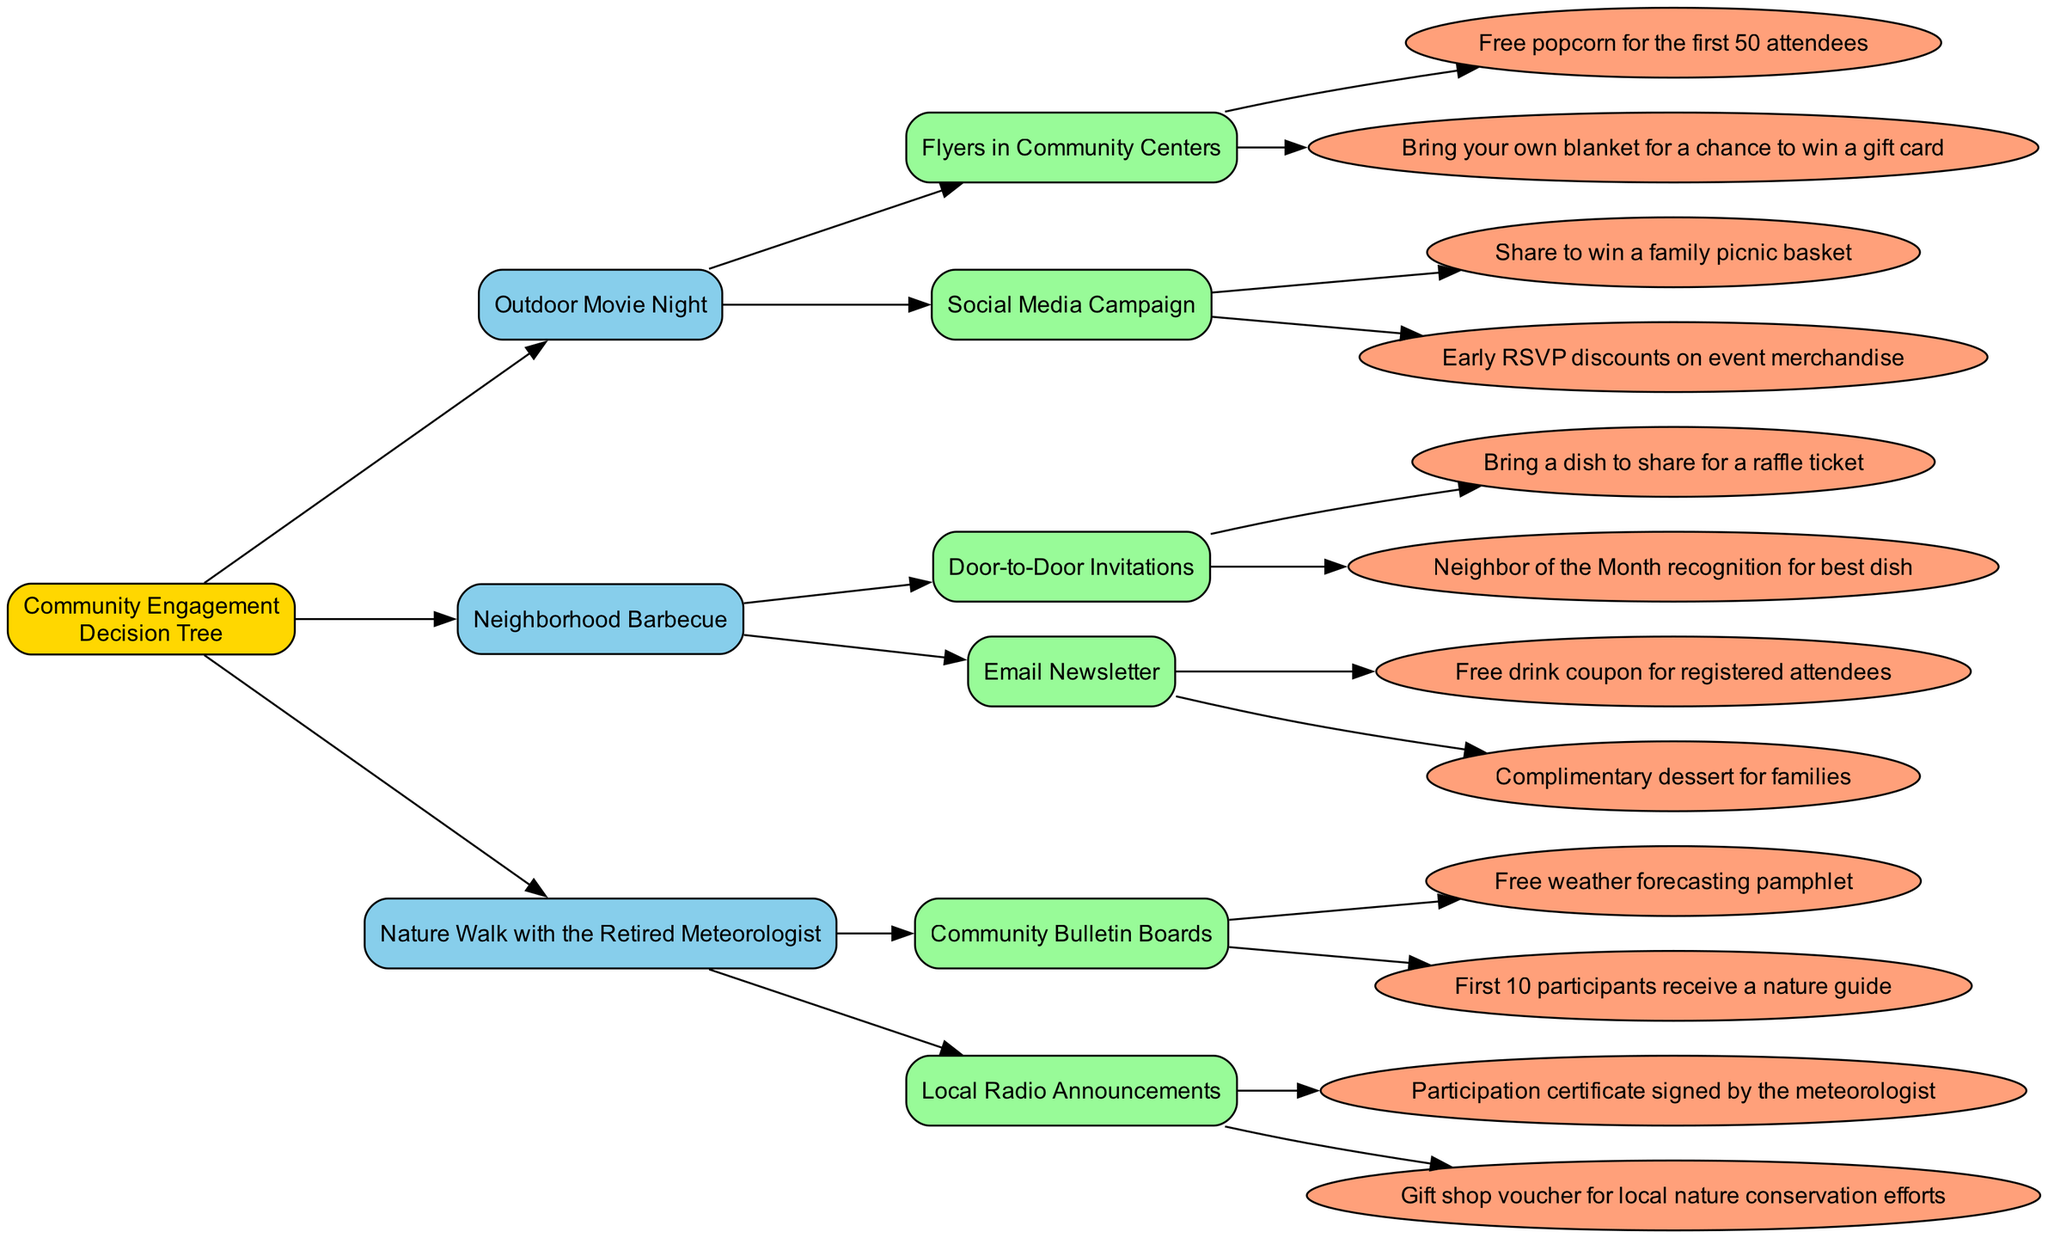What are the two event types listed in the diagram? The diagram shows two specific event types: "Neighborhood Barbecue" and "Nature Walk with the Retired Meteorologist", which can be found under the "Event Type" node.
Answer: Neighborhood Barbecue, Nature Walk with the Retired Meteorologist How many outreach methods are available for the Outdoor Movie Night? The "Outdoor Movie Night" node has two edges leading to the outreach methods: "Flyers in Community Centers" and "Social Media Campaign", indicating that there are two outreach methods for this event.
Answer: 2 What incentive is offered for the first 10 participants in the Nature Walk? Within the "Local Radio Announcements" outreach method, one of the listed incentives clearly specifies that the first 10 participants will receive a "Gift shop voucher for local nature conservation efforts".
Answer: Gift shop voucher for local nature conservation efforts Which outreach method uses door-to-door invites? The "Neighborhood Barbecue" event specifically lists "Door-to-Door Invitations" as its outreach method, which is indicated by an edge branching from the "Neighborhood Barbecue" node.
Answer: Door-to-Door Invitations What is the incentive for those who share the event on social media? Under the "Social Media Campaign" outreach method for the "Outdoor Movie Night", one of the incentives states, "Share to win a family picnic basket," indicating the reward for sharing.
Answer: Share to win a family picnic basket Which event type offers a participation certificate signed by the retired meteorologist? Looking at the "Nature Walk with the Retired Meteorologist" event type, the "Local Radio Announcements" outreach method lists a participation certificate as an incentive, specifically noting it is signed by the meteorologist.
Answer: Nature Walk with the Retired Meteorologist 